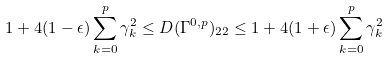<formula> <loc_0><loc_0><loc_500><loc_500>1 + 4 ( 1 - \epsilon ) \sum _ { k = 0 } ^ { p } \gamma _ { k } ^ { 2 } \leq D ( \Gamma ^ { 0 , p } ) _ { 2 2 } \leq 1 + 4 ( 1 + \epsilon ) \sum _ { k = 0 } ^ { p } \gamma _ { k } ^ { 2 }</formula> 